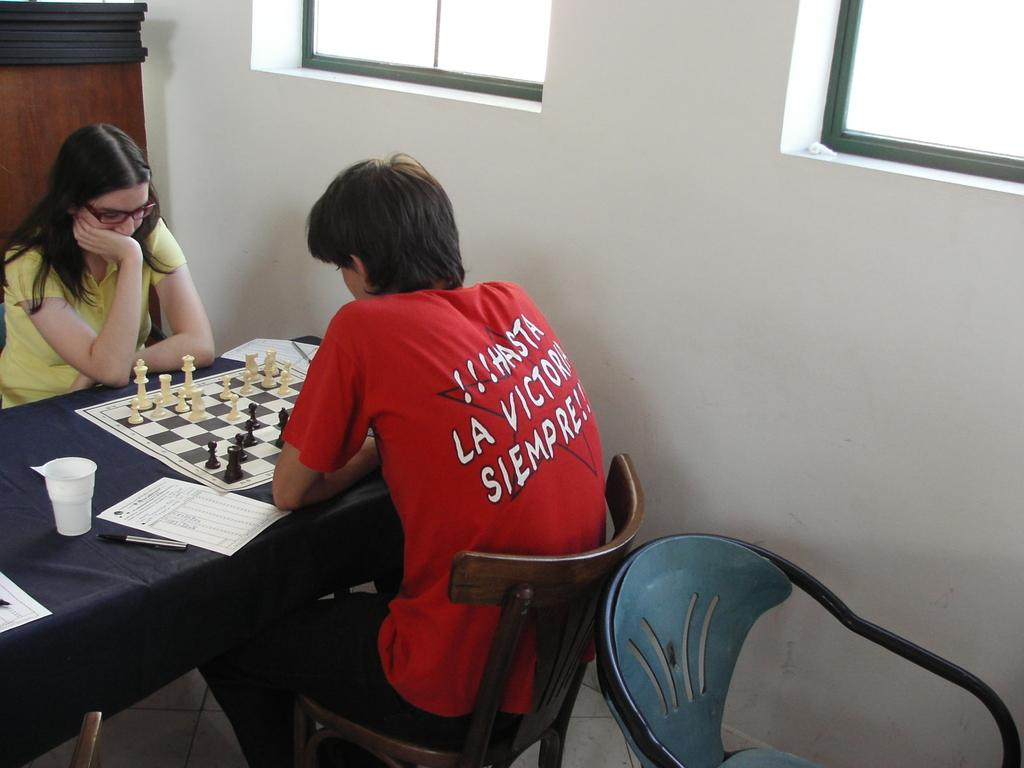How many people are present in the image? There are two people, a man and a woman, present in the image. What are the man and woman doing in the image? Both the man and woman are sitting on chairs. What is on the table in the image? There is a paper, a chess board, and a cup on the table. What can be seen in the background of the image? There is a wall and a window in the background of the image. What type of underwear is the man wearing in the image? There is no information about the man's underwear in the image, as it is not visible or mentioned in the provided facts. How much force is being applied to the chess pieces in the image? There is no indication of force being applied to the chess pieces in the image, as they are stationary on the chess board. 